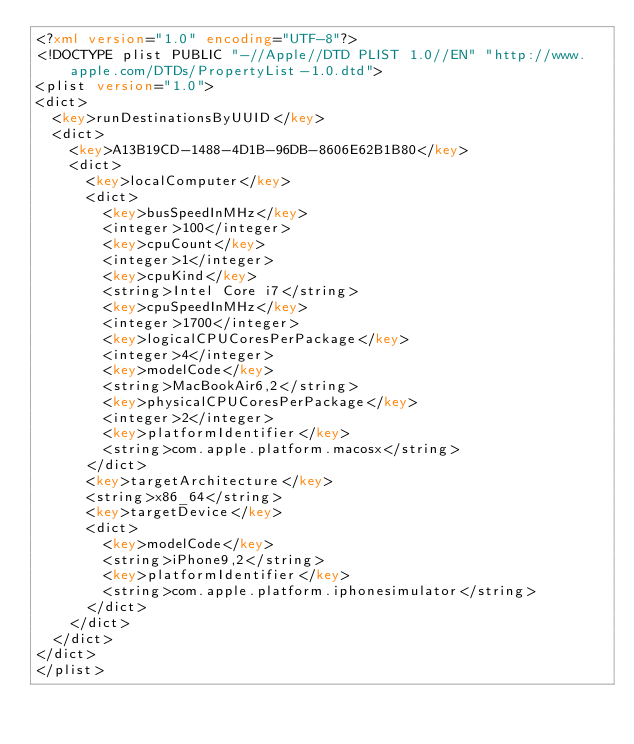<code> <loc_0><loc_0><loc_500><loc_500><_XML_><?xml version="1.0" encoding="UTF-8"?>
<!DOCTYPE plist PUBLIC "-//Apple//DTD PLIST 1.0//EN" "http://www.apple.com/DTDs/PropertyList-1.0.dtd">
<plist version="1.0">
<dict>
	<key>runDestinationsByUUID</key>
	<dict>
		<key>A13B19CD-1488-4D1B-96DB-8606E62B1B80</key>
		<dict>
			<key>localComputer</key>
			<dict>
				<key>busSpeedInMHz</key>
				<integer>100</integer>
				<key>cpuCount</key>
				<integer>1</integer>
				<key>cpuKind</key>
				<string>Intel Core i7</string>
				<key>cpuSpeedInMHz</key>
				<integer>1700</integer>
				<key>logicalCPUCoresPerPackage</key>
				<integer>4</integer>
				<key>modelCode</key>
				<string>MacBookAir6,2</string>
				<key>physicalCPUCoresPerPackage</key>
				<integer>2</integer>
				<key>platformIdentifier</key>
				<string>com.apple.platform.macosx</string>
			</dict>
			<key>targetArchitecture</key>
			<string>x86_64</string>
			<key>targetDevice</key>
			<dict>
				<key>modelCode</key>
				<string>iPhone9,2</string>
				<key>platformIdentifier</key>
				<string>com.apple.platform.iphonesimulator</string>
			</dict>
		</dict>
	</dict>
</dict>
</plist>
</code> 